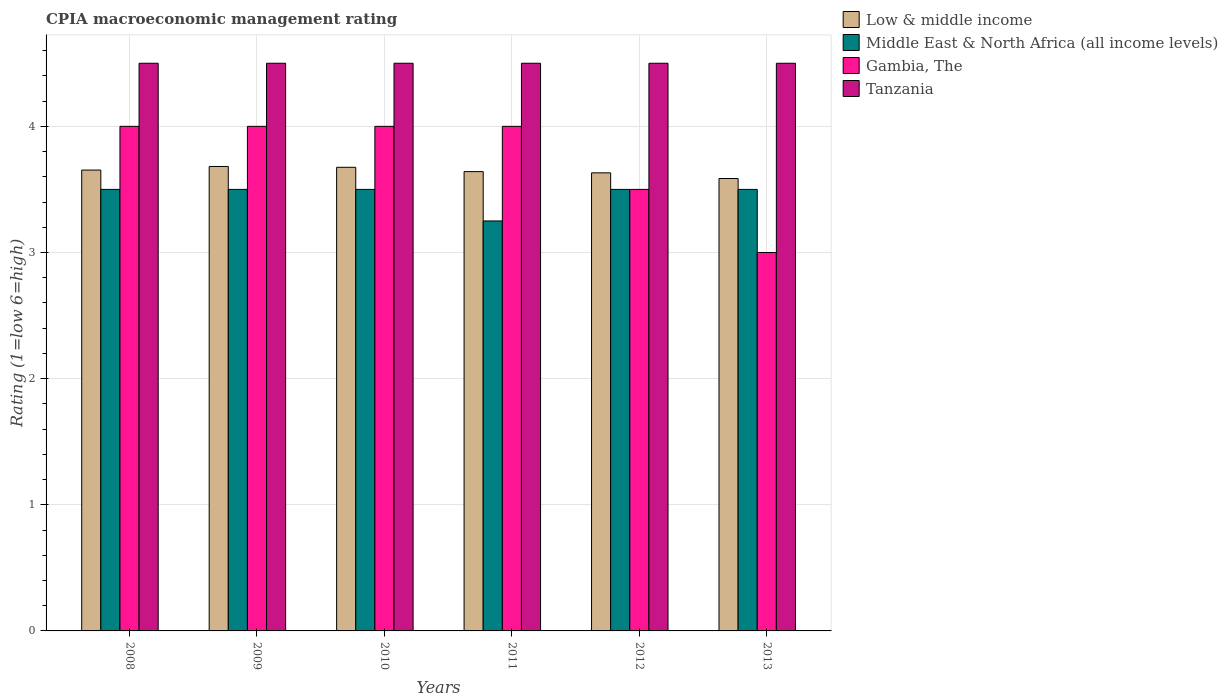Are the number of bars per tick equal to the number of legend labels?
Make the answer very short. Yes. Are the number of bars on each tick of the X-axis equal?
Provide a succinct answer. Yes. How many bars are there on the 5th tick from the left?
Make the answer very short. 4. In how many cases, is the number of bars for a given year not equal to the number of legend labels?
Give a very brief answer. 0. What is the CPIA rating in Tanzania in 2011?
Give a very brief answer. 4.5. Across all years, what is the minimum CPIA rating in Low & middle income?
Ensure brevity in your answer.  3.59. In which year was the CPIA rating in Tanzania minimum?
Your response must be concise. 2008. What is the total CPIA rating in Gambia, The in the graph?
Give a very brief answer. 22.5. What is the difference between the CPIA rating in Low & middle income in 2012 and that in 2013?
Ensure brevity in your answer.  0.04. What is the difference between the CPIA rating in Gambia, The in 2010 and the CPIA rating in Low & middle income in 2012?
Provide a short and direct response. 0.37. What is the average CPIA rating in Tanzania per year?
Provide a short and direct response. 4.5. In the year 2009, what is the difference between the CPIA rating in Low & middle income and CPIA rating in Gambia, The?
Ensure brevity in your answer.  -0.32. What is the ratio of the CPIA rating in Middle East & North Africa (all income levels) in 2009 to that in 2013?
Your answer should be very brief. 1. What is the difference between the highest and the second highest CPIA rating in Tanzania?
Offer a very short reply. 0. In how many years, is the CPIA rating in Tanzania greater than the average CPIA rating in Tanzania taken over all years?
Provide a succinct answer. 0. Is it the case that in every year, the sum of the CPIA rating in Gambia, The and CPIA rating in Tanzania is greater than the sum of CPIA rating in Low & middle income and CPIA rating in Middle East & North Africa (all income levels)?
Your answer should be very brief. Yes. What does the 2nd bar from the left in 2009 represents?
Your answer should be compact. Middle East & North Africa (all income levels). What does the 1st bar from the right in 2012 represents?
Your answer should be compact. Tanzania. Is it the case that in every year, the sum of the CPIA rating in Tanzania and CPIA rating in Low & middle income is greater than the CPIA rating in Middle East & North Africa (all income levels)?
Your response must be concise. Yes. How many bars are there?
Provide a succinct answer. 24. Are all the bars in the graph horizontal?
Your response must be concise. No. How many years are there in the graph?
Your answer should be compact. 6. Does the graph contain any zero values?
Your answer should be very brief. No. How are the legend labels stacked?
Keep it short and to the point. Vertical. What is the title of the graph?
Your answer should be very brief. CPIA macroeconomic management rating. Does "Tanzania" appear as one of the legend labels in the graph?
Make the answer very short. Yes. What is the label or title of the X-axis?
Keep it short and to the point. Years. What is the Rating (1=low 6=high) of Low & middle income in 2008?
Keep it short and to the point. 3.65. What is the Rating (1=low 6=high) of Middle East & North Africa (all income levels) in 2008?
Make the answer very short. 3.5. What is the Rating (1=low 6=high) in Gambia, The in 2008?
Offer a terse response. 4. What is the Rating (1=low 6=high) of Low & middle income in 2009?
Make the answer very short. 3.68. What is the Rating (1=low 6=high) in Tanzania in 2009?
Your answer should be compact. 4.5. What is the Rating (1=low 6=high) in Low & middle income in 2010?
Offer a terse response. 3.68. What is the Rating (1=low 6=high) in Middle East & North Africa (all income levels) in 2010?
Offer a very short reply. 3.5. What is the Rating (1=low 6=high) in Tanzania in 2010?
Make the answer very short. 4.5. What is the Rating (1=low 6=high) of Low & middle income in 2011?
Your response must be concise. 3.64. What is the Rating (1=low 6=high) of Middle East & North Africa (all income levels) in 2011?
Offer a very short reply. 3.25. What is the Rating (1=low 6=high) in Gambia, The in 2011?
Your response must be concise. 4. What is the Rating (1=low 6=high) in Tanzania in 2011?
Offer a terse response. 4.5. What is the Rating (1=low 6=high) in Low & middle income in 2012?
Your answer should be compact. 3.63. What is the Rating (1=low 6=high) of Middle East & North Africa (all income levels) in 2012?
Your answer should be very brief. 3.5. What is the Rating (1=low 6=high) in Gambia, The in 2012?
Your answer should be compact. 3.5. What is the Rating (1=low 6=high) in Low & middle income in 2013?
Provide a short and direct response. 3.59. What is the Rating (1=low 6=high) of Middle East & North Africa (all income levels) in 2013?
Make the answer very short. 3.5. What is the Rating (1=low 6=high) in Gambia, The in 2013?
Offer a very short reply. 3. Across all years, what is the maximum Rating (1=low 6=high) of Low & middle income?
Make the answer very short. 3.68. Across all years, what is the maximum Rating (1=low 6=high) in Gambia, The?
Your answer should be very brief. 4. Across all years, what is the maximum Rating (1=low 6=high) in Tanzania?
Ensure brevity in your answer.  4.5. Across all years, what is the minimum Rating (1=low 6=high) of Low & middle income?
Offer a terse response. 3.59. Across all years, what is the minimum Rating (1=low 6=high) of Middle East & North Africa (all income levels)?
Provide a short and direct response. 3.25. Across all years, what is the minimum Rating (1=low 6=high) of Gambia, The?
Your answer should be compact. 3. What is the total Rating (1=low 6=high) in Low & middle income in the graph?
Provide a succinct answer. 21.87. What is the total Rating (1=low 6=high) of Middle East & North Africa (all income levels) in the graph?
Offer a very short reply. 20.75. What is the difference between the Rating (1=low 6=high) in Low & middle income in 2008 and that in 2009?
Offer a terse response. -0.03. What is the difference between the Rating (1=low 6=high) of Tanzania in 2008 and that in 2009?
Give a very brief answer. 0. What is the difference between the Rating (1=low 6=high) of Low & middle income in 2008 and that in 2010?
Make the answer very short. -0.02. What is the difference between the Rating (1=low 6=high) of Middle East & North Africa (all income levels) in 2008 and that in 2010?
Provide a short and direct response. 0. What is the difference between the Rating (1=low 6=high) of Low & middle income in 2008 and that in 2011?
Provide a succinct answer. 0.01. What is the difference between the Rating (1=low 6=high) in Gambia, The in 2008 and that in 2011?
Ensure brevity in your answer.  0. What is the difference between the Rating (1=low 6=high) in Low & middle income in 2008 and that in 2012?
Make the answer very short. 0.02. What is the difference between the Rating (1=low 6=high) of Middle East & North Africa (all income levels) in 2008 and that in 2012?
Your answer should be very brief. 0. What is the difference between the Rating (1=low 6=high) of Tanzania in 2008 and that in 2012?
Ensure brevity in your answer.  0. What is the difference between the Rating (1=low 6=high) in Low & middle income in 2008 and that in 2013?
Your answer should be very brief. 0.07. What is the difference between the Rating (1=low 6=high) of Middle East & North Africa (all income levels) in 2008 and that in 2013?
Your answer should be compact. 0. What is the difference between the Rating (1=low 6=high) of Tanzania in 2008 and that in 2013?
Your answer should be compact. 0. What is the difference between the Rating (1=low 6=high) of Low & middle income in 2009 and that in 2010?
Provide a succinct answer. 0.01. What is the difference between the Rating (1=low 6=high) of Middle East & North Africa (all income levels) in 2009 and that in 2010?
Offer a very short reply. 0. What is the difference between the Rating (1=low 6=high) of Tanzania in 2009 and that in 2010?
Your response must be concise. 0. What is the difference between the Rating (1=low 6=high) in Low & middle income in 2009 and that in 2011?
Your answer should be compact. 0.04. What is the difference between the Rating (1=low 6=high) of Middle East & North Africa (all income levels) in 2009 and that in 2011?
Keep it short and to the point. 0.25. What is the difference between the Rating (1=low 6=high) of Gambia, The in 2009 and that in 2011?
Make the answer very short. 0. What is the difference between the Rating (1=low 6=high) of Tanzania in 2009 and that in 2011?
Make the answer very short. 0. What is the difference between the Rating (1=low 6=high) in Low & middle income in 2009 and that in 2012?
Provide a succinct answer. 0.05. What is the difference between the Rating (1=low 6=high) of Gambia, The in 2009 and that in 2012?
Provide a succinct answer. 0.5. What is the difference between the Rating (1=low 6=high) in Tanzania in 2009 and that in 2012?
Offer a terse response. 0. What is the difference between the Rating (1=low 6=high) in Low & middle income in 2009 and that in 2013?
Provide a short and direct response. 0.1. What is the difference between the Rating (1=low 6=high) in Low & middle income in 2010 and that in 2011?
Your response must be concise. 0.03. What is the difference between the Rating (1=low 6=high) in Gambia, The in 2010 and that in 2011?
Offer a very short reply. 0. What is the difference between the Rating (1=low 6=high) of Tanzania in 2010 and that in 2011?
Make the answer very short. 0. What is the difference between the Rating (1=low 6=high) of Low & middle income in 2010 and that in 2012?
Your answer should be compact. 0.04. What is the difference between the Rating (1=low 6=high) in Low & middle income in 2010 and that in 2013?
Offer a very short reply. 0.09. What is the difference between the Rating (1=low 6=high) of Middle East & North Africa (all income levels) in 2010 and that in 2013?
Keep it short and to the point. 0. What is the difference between the Rating (1=low 6=high) in Gambia, The in 2010 and that in 2013?
Give a very brief answer. 1. What is the difference between the Rating (1=low 6=high) of Tanzania in 2010 and that in 2013?
Your answer should be very brief. 0. What is the difference between the Rating (1=low 6=high) in Low & middle income in 2011 and that in 2012?
Your answer should be compact. 0.01. What is the difference between the Rating (1=low 6=high) of Middle East & North Africa (all income levels) in 2011 and that in 2012?
Provide a succinct answer. -0.25. What is the difference between the Rating (1=low 6=high) in Low & middle income in 2011 and that in 2013?
Offer a very short reply. 0.05. What is the difference between the Rating (1=low 6=high) of Middle East & North Africa (all income levels) in 2011 and that in 2013?
Give a very brief answer. -0.25. What is the difference between the Rating (1=low 6=high) of Gambia, The in 2011 and that in 2013?
Keep it short and to the point. 1. What is the difference between the Rating (1=low 6=high) in Tanzania in 2011 and that in 2013?
Offer a terse response. 0. What is the difference between the Rating (1=low 6=high) in Low & middle income in 2012 and that in 2013?
Provide a succinct answer. 0.04. What is the difference between the Rating (1=low 6=high) of Middle East & North Africa (all income levels) in 2012 and that in 2013?
Offer a very short reply. 0. What is the difference between the Rating (1=low 6=high) in Gambia, The in 2012 and that in 2013?
Offer a very short reply. 0.5. What is the difference between the Rating (1=low 6=high) of Low & middle income in 2008 and the Rating (1=low 6=high) of Middle East & North Africa (all income levels) in 2009?
Ensure brevity in your answer.  0.15. What is the difference between the Rating (1=low 6=high) in Low & middle income in 2008 and the Rating (1=low 6=high) in Gambia, The in 2009?
Offer a very short reply. -0.35. What is the difference between the Rating (1=low 6=high) of Low & middle income in 2008 and the Rating (1=low 6=high) of Tanzania in 2009?
Make the answer very short. -0.85. What is the difference between the Rating (1=low 6=high) in Middle East & North Africa (all income levels) in 2008 and the Rating (1=low 6=high) in Gambia, The in 2009?
Make the answer very short. -0.5. What is the difference between the Rating (1=low 6=high) of Middle East & North Africa (all income levels) in 2008 and the Rating (1=low 6=high) of Tanzania in 2009?
Make the answer very short. -1. What is the difference between the Rating (1=low 6=high) of Gambia, The in 2008 and the Rating (1=low 6=high) of Tanzania in 2009?
Provide a short and direct response. -0.5. What is the difference between the Rating (1=low 6=high) in Low & middle income in 2008 and the Rating (1=low 6=high) in Middle East & North Africa (all income levels) in 2010?
Your answer should be compact. 0.15. What is the difference between the Rating (1=low 6=high) in Low & middle income in 2008 and the Rating (1=low 6=high) in Gambia, The in 2010?
Provide a short and direct response. -0.35. What is the difference between the Rating (1=low 6=high) of Low & middle income in 2008 and the Rating (1=low 6=high) of Tanzania in 2010?
Keep it short and to the point. -0.85. What is the difference between the Rating (1=low 6=high) in Middle East & North Africa (all income levels) in 2008 and the Rating (1=low 6=high) in Tanzania in 2010?
Offer a terse response. -1. What is the difference between the Rating (1=low 6=high) of Low & middle income in 2008 and the Rating (1=low 6=high) of Middle East & North Africa (all income levels) in 2011?
Ensure brevity in your answer.  0.4. What is the difference between the Rating (1=low 6=high) in Low & middle income in 2008 and the Rating (1=low 6=high) in Gambia, The in 2011?
Ensure brevity in your answer.  -0.35. What is the difference between the Rating (1=low 6=high) of Low & middle income in 2008 and the Rating (1=low 6=high) of Tanzania in 2011?
Give a very brief answer. -0.85. What is the difference between the Rating (1=low 6=high) in Middle East & North Africa (all income levels) in 2008 and the Rating (1=low 6=high) in Gambia, The in 2011?
Keep it short and to the point. -0.5. What is the difference between the Rating (1=low 6=high) of Middle East & North Africa (all income levels) in 2008 and the Rating (1=low 6=high) of Tanzania in 2011?
Provide a succinct answer. -1. What is the difference between the Rating (1=low 6=high) in Low & middle income in 2008 and the Rating (1=low 6=high) in Middle East & North Africa (all income levels) in 2012?
Your answer should be compact. 0.15. What is the difference between the Rating (1=low 6=high) of Low & middle income in 2008 and the Rating (1=low 6=high) of Gambia, The in 2012?
Provide a succinct answer. 0.15. What is the difference between the Rating (1=low 6=high) in Low & middle income in 2008 and the Rating (1=low 6=high) in Tanzania in 2012?
Your response must be concise. -0.85. What is the difference between the Rating (1=low 6=high) in Middle East & North Africa (all income levels) in 2008 and the Rating (1=low 6=high) in Gambia, The in 2012?
Keep it short and to the point. 0. What is the difference between the Rating (1=low 6=high) in Middle East & North Africa (all income levels) in 2008 and the Rating (1=low 6=high) in Tanzania in 2012?
Make the answer very short. -1. What is the difference between the Rating (1=low 6=high) of Gambia, The in 2008 and the Rating (1=low 6=high) of Tanzania in 2012?
Offer a terse response. -0.5. What is the difference between the Rating (1=low 6=high) of Low & middle income in 2008 and the Rating (1=low 6=high) of Middle East & North Africa (all income levels) in 2013?
Your answer should be very brief. 0.15. What is the difference between the Rating (1=low 6=high) in Low & middle income in 2008 and the Rating (1=low 6=high) in Gambia, The in 2013?
Offer a terse response. 0.65. What is the difference between the Rating (1=low 6=high) of Low & middle income in 2008 and the Rating (1=low 6=high) of Tanzania in 2013?
Your response must be concise. -0.85. What is the difference between the Rating (1=low 6=high) of Middle East & North Africa (all income levels) in 2008 and the Rating (1=low 6=high) of Tanzania in 2013?
Provide a short and direct response. -1. What is the difference between the Rating (1=low 6=high) of Gambia, The in 2008 and the Rating (1=low 6=high) of Tanzania in 2013?
Offer a terse response. -0.5. What is the difference between the Rating (1=low 6=high) of Low & middle income in 2009 and the Rating (1=low 6=high) of Middle East & North Africa (all income levels) in 2010?
Give a very brief answer. 0.18. What is the difference between the Rating (1=low 6=high) in Low & middle income in 2009 and the Rating (1=low 6=high) in Gambia, The in 2010?
Keep it short and to the point. -0.32. What is the difference between the Rating (1=low 6=high) in Low & middle income in 2009 and the Rating (1=low 6=high) in Tanzania in 2010?
Offer a very short reply. -0.82. What is the difference between the Rating (1=low 6=high) of Middle East & North Africa (all income levels) in 2009 and the Rating (1=low 6=high) of Tanzania in 2010?
Provide a short and direct response. -1. What is the difference between the Rating (1=low 6=high) of Gambia, The in 2009 and the Rating (1=low 6=high) of Tanzania in 2010?
Provide a succinct answer. -0.5. What is the difference between the Rating (1=low 6=high) in Low & middle income in 2009 and the Rating (1=low 6=high) in Middle East & North Africa (all income levels) in 2011?
Ensure brevity in your answer.  0.43. What is the difference between the Rating (1=low 6=high) of Low & middle income in 2009 and the Rating (1=low 6=high) of Gambia, The in 2011?
Keep it short and to the point. -0.32. What is the difference between the Rating (1=low 6=high) in Low & middle income in 2009 and the Rating (1=low 6=high) in Tanzania in 2011?
Provide a succinct answer. -0.82. What is the difference between the Rating (1=low 6=high) in Middle East & North Africa (all income levels) in 2009 and the Rating (1=low 6=high) in Gambia, The in 2011?
Provide a succinct answer. -0.5. What is the difference between the Rating (1=low 6=high) in Low & middle income in 2009 and the Rating (1=low 6=high) in Middle East & North Africa (all income levels) in 2012?
Ensure brevity in your answer.  0.18. What is the difference between the Rating (1=low 6=high) in Low & middle income in 2009 and the Rating (1=low 6=high) in Gambia, The in 2012?
Provide a short and direct response. 0.18. What is the difference between the Rating (1=low 6=high) in Low & middle income in 2009 and the Rating (1=low 6=high) in Tanzania in 2012?
Offer a terse response. -0.82. What is the difference between the Rating (1=low 6=high) in Middle East & North Africa (all income levels) in 2009 and the Rating (1=low 6=high) in Gambia, The in 2012?
Offer a terse response. 0. What is the difference between the Rating (1=low 6=high) of Low & middle income in 2009 and the Rating (1=low 6=high) of Middle East & North Africa (all income levels) in 2013?
Your response must be concise. 0.18. What is the difference between the Rating (1=low 6=high) of Low & middle income in 2009 and the Rating (1=low 6=high) of Gambia, The in 2013?
Make the answer very short. 0.68. What is the difference between the Rating (1=low 6=high) of Low & middle income in 2009 and the Rating (1=low 6=high) of Tanzania in 2013?
Offer a very short reply. -0.82. What is the difference between the Rating (1=low 6=high) in Gambia, The in 2009 and the Rating (1=low 6=high) in Tanzania in 2013?
Ensure brevity in your answer.  -0.5. What is the difference between the Rating (1=low 6=high) of Low & middle income in 2010 and the Rating (1=low 6=high) of Middle East & North Africa (all income levels) in 2011?
Your answer should be very brief. 0.43. What is the difference between the Rating (1=low 6=high) in Low & middle income in 2010 and the Rating (1=low 6=high) in Gambia, The in 2011?
Provide a succinct answer. -0.32. What is the difference between the Rating (1=low 6=high) in Low & middle income in 2010 and the Rating (1=low 6=high) in Tanzania in 2011?
Your answer should be very brief. -0.82. What is the difference between the Rating (1=low 6=high) of Middle East & North Africa (all income levels) in 2010 and the Rating (1=low 6=high) of Gambia, The in 2011?
Offer a very short reply. -0.5. What is the difference between the Rating (1=low 6=high) in Middle East & North Africa (all income levels) in 2010 and the Rating (1=low 6=high) in Tanzania in 2011?
Your answer should be very brief. -1. What is the difference between the Rating (1=low 6=high) in Low & middle income in 2010 and the Rating (1=low 6=high) in Middle East & North Africa (all income levels) in 2012?
Provide a short and direct response. 0.18. What is the difference between the Rating (1=low 6=high) of Low & middle income in 2010 and the Rating (1=low 6=high) of Gambia, The in 2012?
Provide a short and direct response. 0.18. What is the difference between the Rating (1=low 6=high) in Low & middle income in 2010 and the Rating (1=low 6=high) in Tanzania in 2012?
Provide a short and direct response. -0.82. What is the difference between the Rating (1=low 6=high) of Middle East & North Africa (all income levels) in 2010 and the Rating (1=low 6=high) of Gambia, The in 2012?
Offer a terse response. 0. What is the difference between the Rating (1=low 6=high) of Low & middle income in 2010 and the Rating (1=low 6=high) of Middle East & North Africa (all income levels) in 2013?
Offer a terse response. 0.18. What is the difference between the Rating (1=low 6=high) in Low & middle income in 2010 and the Rating (1=low 6=high) in Gambia, The in 2013?
Your answer should be very brief. 0.68. What is the difference between the Rating (1=low 6=high) in Low & middle income in 2010 and the Rating (1=low 6=high) in Tanzania in 2013?
Ensure brevity in your answer.  -0.82. What is the difference between the Rating (1=low 6=high) in Middle East & North Africa (all income levels) in 2010 and the Rating (1=low 6=high) in Gambia, The in 2013?
Give a very brief answer. 0.5. What is the difference between the Rating (1=low 6=high) in Middle East & North Africa (all income levels) in 2010 and the Rating (1=low 6=high) in Tanzania in 2013?
Offer a terse response. -1. What is the difference between the Rating (1=low 6=high) of Gambia, The in 2010 and the Rating (1=low 6=high) of Tanzania in 2013?
Provide a succinct answer. -0.5. What is the difference between the Rating (1=low 6=high) of Low & middle income in 2011 and the Rating (1=low 6=high) of Middle East & North Africa (all income levels) in 2012?
Keep it short and to the point. 0.14. What is the difference between the Rating (1=low 6=high) in Low & middle income in 2011 and the Rating (1=low 6=high) in Gambia, The in 2012?
Provide a succinct answer. 0.14. What is the difference between the Rating (1=low 6=high) of Low & middle income in 2011 and the Rating (1=low 6=high) of Tanzania in 2012?
Keep it short and to the point. -0.86. What is the difference between the Rating (1=low 6=high) in Middle East & North Africa (all income levels) in 2011 and the Rating (1=low 6=high) in Tanzania in 2012?
Your answer should be very brief. -1.25. What is the difference between the Rating (1=low 6=high) of Gambia, The in 2011 and the Rating (1=low 6=high) of Tanzania in 2012?
Provide a succinct answer. -0.5. What is the difference between the Rating (1=low 6=high) in Low & middle income in 2011 and the Rating (1=low 6=high) in Middle East & North Africa (all income levels) in 2013?
Offer a terse response. 0.14. What is the difference between the Rating (1=low 6=high) of Low & middle income in 2011 and the Rating (1=low 6=high) of Gambia, The in 2013?
Provide a short and direct response. 0.64. What is the difference between the Rating (1=low 6=high) of Low & middle income in 2011 and the Rating (1=low 6=high) of Tanzania in 2013?
Give a very brief answer. -0.86. What is the difference between the Rating (1=low 6=high) in Middle East & North Africa (all income levels) in 2011 and the Rating (1=low 6=high) in Tanzania in 2013?
Ensure brevity in your answer.  -1.25. What is the difference between the Rating (1=low 6=high) of Gambia, The in 2011 and the Rating (1=low 6=high) of Tanzania in 2013?
Make the answer very short. -0.5. What is the difference between the Rating (1=low 6=high) of Low & middle income in 2012 and the Rating (1=low 6=high) of Middle East & North Africa (all income levels) in 2013?
Provide a succinct answer. 0.13. What is the difference between the Rating (1=low 6=high) in Low & middle income in 2012 and the Rating (1=low 6=high) in Gambia, The in 2013?
Offer a terse response. 0.63. What is the difference between the Rating (1=low 6=high) of Low & middle income in 2012 and the Rating (1=low 6=high) of Tanzania in 2013?
Your response must be concise. -0.87. What is the difference between the Rating (1=low 6=high) of Middle East & North Africa (all income levels) in 2012 and the Rating (1=low 6=high) of Gambia, The in 2013?
Provide a succinct answer. 0.5. What is the average Rating (1=low 6=high) in Low & middle income per year?
Offer a very short reply. 3.64. What is the average Rating (1=low 6=high) in Middle East & North Africa (all income levels) per year?
Give a very brief answer. 3.46. What is the average Rating (1=low 6=high) of Gambia, The per year?
Keep it short and to the point. 3.75. In the year 2008, what is the difference between the Rating (1=low 6=high) in Low & middle income and Rating (1=low 6=high) in Middle East & North Africa (all income levels)?
Offer a terse response. 0.15. In the year 2008, what is the difference between the Rating (1=low 6=high) in Low & middle income and Rating (1=low 6=high) in Gambia, The?
Ensure brevity in your answer.  -0.35. In the year 2008, what is the difference between the Rating (1=low 6=high) of Low & middle income and Rating (1=low 6=high) of Tanzania?
Offer a terse response. -0.85. In the year 2008, what is the difference between the Rating (1=low 6=high) of Middle East & North Africa (all income levels) and Rating (1=low 6=high) of Gambia, The?
Provide a short and direct response. -0.5. In the year 2008, what is the difference between the Rating (1=low 6=high) of Middle East & North Africa (all income levels) and Rating (1=low 6=high) of Tanzania?
Provide a short and direct response. -1. In the year 2009, what is the difference between the Rating (1=low 6=high) of Low & middle income and Rating (1=low 6=high) of Middle East & North Africa (all income levels)?
Your answer should be compact. 0.18. In the year 2009, what is the difference between the Rating (1=low 6=high) in Low & middle income and Rating (1=low 6=high) in Gambia, The?
Offer a terse response. -0.32. In the year 2009, what is the difference between the Rating (1=low 6=high) in Low & middle income and Rating (1=low 6=high) in Tanzania?
Your answer should be very brief. -0.82. In the year 2009, what is the difference between the Rating (1=low 6=high) in Middle East & North Africa (all income levels) and Rating (1=low 6=high) in Gambia, The?
Provide a short and direct response. -0.5. In the year 2010, what is the difference between the Rating (1=low 6=high) of Low & middle income and Rating (1=low 6=high) of Middle East & North Africa (all income levels)?
Ensure brevity in your answer.  0.18. In the year 2010, what is the difference between the Rating (1=low 6=high) of Low & middle income and Rating (1=low 6=high) of Gambia, The?
Offer a terse response. -0.32. In the year 2010, what is the difference between the Rating (1=low 6=high) of Low & middle income and Rating (1=low 6=high) of Tanzania?
Your answer should be compact. -0.82. In the year 2010, what is the difference between the Rating (1=low 6=high) in Middle East & North Africa (all income levels) and Rating (1=low 6=high) in Gambia, The?
Offer a terse response. -0.5. In the year 2010, what is the difference between the Rating (1=low 6=high) in Gambia, The and Rating (1=low 6=high) in Tanzania?
Offer a very short reply. -0.5. In the year 2011, what is the difference between the Rating (1=low 6=high) in Low & middle income and Rating (1=low 6=high) in Middle East & North Africa (all income levels)?
Your response must be concise. 0.39. In the year 2011, what is the difference between the Rating (1=low 6=high) of Low & middle income and Rating (1=low 6=high) of Gambia, The?
Ensure brevity in your answer.  -0.36. In the year 2011, what is the difference between the Rating (1=low 6=high) of Low & middle income and Rating (1=low 6=high) of Tanzania?
Make the answer very short. -0.86. In the year 2011, what is the difference between the Rating (1=low 6=high) in Middle East & North Africa (all income levels) and Rating (1=low 6=high) in Gambia, The?
Give a very brief answer. -0.75. In the year 2011, what is the difference between the Rating (1=low 6=high) of Middle East & North Africa (all income levels) and Rating (1=low 6=high) of Tanzania?
Give a very brief answer. -1.25. In the year 2012, what is the difference between the Rating (1=low 6=high) in Low & middle income and Rating (1=low 6=high) in Middle East & North Africa (all income levels)?
Ensure brevity in your answer.  0.13. In the year 2012, what is the difference between the Rating (1=low 6=high) of Low & middle income and Rating (1=low 6=high) of Gambia, The?
Your response must be concise. 0.13. In the year 2012, what is the difference between the Rating (1=low 6=high) in Low & middle income and Rating (1=low 6=high) in Tanzania?
Make the answer very short. -0.87. In the year 2012, what is the difference between the Rating (1=low 6=high) of Middle East & North Africa (all income levels) and Rating (1=low 6=high) of Gambia, The?
Offer a very short reply. 0. In the year 2012, what is the difference between the Rating (1=low 6=high) of Middle East & North Africa (all income levels) and Rating (1=low 6=high) of Tanzania?
Keep it short and to the point. -1. In the year 2012, what is the difference between the Rating (1=low 6=high) of Gambia, The and Rating (1=low 6=high) of Tanzania?
Keep it short and to the point. -1. In the year 2013, what is the difference between the Rating (1=low 6=high) of Low & middle income and Rating (1=low 6=high) of Middle East & North Africa (all income levels)?
Offer a terse response. 0.09. In the year 2013, what is the difference between the Rating (1=low 6=high) of Low & middle income and Rating (1=low 6=high) of Gambia, The?
Your answer should be compact. 0.59. In the year 2013, what is the difference between the Rating (1=low 6=high) in Low & middle income and Rating (1=low 6=high) in Tanzania?
Give a very brief answer. -0.91. In the year 2013, what is the difference between the Rating (1=low 6=high) of Middle East & North Africa (all income levels) and Rating (1=low 6=high) of Gambia, The?
Your answer should be very brief. 0.5. What is the ratio of the Rating (1=low 6=high) of Low & middle income in 2008 to that in 2009?
Your answer should be very brief. 0.99. What is the ratio of the Rating (1=low 6=high) of Middle East & North Africa (all income levels) in 2008 to that in 2010?
Keep it short and to the point. 1. What is the ratio of the Rating (1=low 6=high) in Gambia, The in 2008 to that in 2010?
Offer a very short reply. 1. What is the ratio of the Rating (1=low 6=high) of Low & middle income in 2008 to that in 2011?
Ensure brevity in your answer.  1. What is the ratio of the Rating (1=low 6=high) of Middle East & North Africa (all income levels) in 2008 to that in 2011?
Give a very brief answer. 1.08. What is the ratio of the Rating (1=low 6=high) in Low & middle income in 2008 to that in 2012?
Your answer should be very brief. 1.01. What is the ratio of the Rating (1=low 6=high) in Tanzania in 2008 to that in 2012?
Keep it short and to the point. 1. What is the ratio of the Rating (1=low 6=high) of Low & middle income in 2008 to that in 2013?
Offer a very short reply. 1.02. What is the ratio of the Rating (1=low 6=high) in Middle East & North Africa (all income levels) in 2008 to that in 2013?
Ensure brevity in your answer.  1. What is the ratio of the Rating (1=low 6=high) in Gambia, The in 2008 to that in 2013?
Your response must be concise. 1.33. What is the ratio of the Rating (1=low 6=high) in Tanzania in 2008 to that in 2013?
Your response must be concise. 1. What is the ratio of the Rating (1=low 6=high) in Low & middle income in 2009 to that in 2011?
Give a very brief answer. 1.01. What is the ratio of the Rating (1=low 6=high) in Gambia, The in 2009 to that in 2011?
Make the answer very short. 1. What is the ratio of the Rating (1=low 6=high) in Low & middle income in 2009 to that in 2012?
Make the answer very short. 1.01. What is the ratio of the Rating (1=low 6=high) in Middle East & North Africa (all income levels) in 2009 to that in 2012?
Your answer should be compact. 1. What is the ratio of the Rating (1=low 6=high) of Low & middle income in 2009 to that in 2013?
Your response must be concise. 1.03. What is the ratio of the Rating (1=low 6=high) in Low & middle income in 2010 to that in 2011?
Provide a short and direct response. 1.01. What is the ratio of the Rating (1=low 6=high) in Low & middle income in 2010 to that in 2012?
Your response must be concise. 1.01. What is the ratio of the Rating (1=low 6=high) of Low & middle income in 2010 to that in 2013?
Provide a short and direct response. 1.02. What is the ratio of the Rating (1=low 6=high) of Middle East & North Africa (all income levels) in 2010 to that in 2013?
Give a very brief answer. 1. What is the ratio of the Rating (1=low 6=high) in Low & middle income in 2011 to that in 2012?
Offer a terse response. 1. What is the ratio of the Rating (1=low 6=high) in Gambia, The in 2011 to that in 2012?
Your answer should be very brief. 1.14. What is the ratio of the Rating (1=low 6=high) in Tanzania in 2011 to that in 2012?
Provide a short and direct response. 1. What is the ratio of the Rating (1=low 6=high) of Low & middle income in 2011 to that in 2013?
Make the answer very short. 1.02. What is the ratio of the Rating (1=low 6=high) in Middle East & North Africa (all income levels) in 2011 to that in 2013?
Provide a short and direct response. 0.93. What is the ratio of the Rating (1=low 6=high) of Tanzania in 2011 to that in 2013?
Offer a terse response. 1. What is the ratio of the Rating (1=low 6=high) in Low & middle income in 2012 to that in 2013?
Offer a very short reply. 1.01. What is the ratio of the Rating (1=low 6=high) of Gambia, The in 2012 to that in 2013?
Provide a short and direct response. 1.17. What is the difference between the highest and the second highest Rating (1=low 6=high) of Low & middle income?
Offer a terse response. 0.01. What is the difference between the highest and the second highest Rating (1=low 6=high) in Middle East & North Africa (all income levels)?
Offer a terse response. 0. What is the difference between the highest and the second highest Rating (1=low 6=high) of Gambia, The?
Ensure brevity in your answer.  0. What is the difference between the highest and the lowest Rating (1=low 6=high) in Low & middle income?
Ensure brevity in your answer.  0.1. What is the difference between the highest and the lowest Rating (1=low 6=high) in Tanzania?
Make the answer very short. 0. 